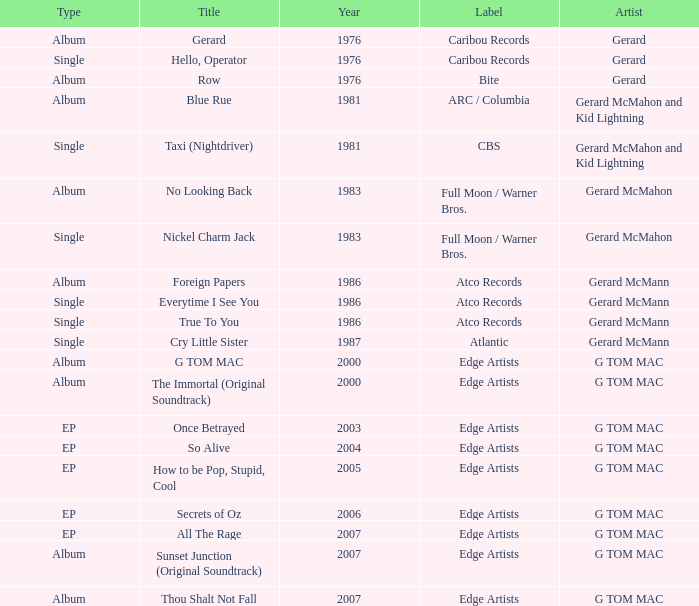Which Title has a Type of album and a Year larger than 1986? G TOM MAC, The Immortal (Original Soundtrack), Sunset Junction (Original Soundtrack), Thou Shalt Not Fall. 